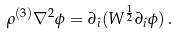<formula> <loc_0><loc_0><loc_500><loc_500>\rho ^ { ( 3 ) } \nabla ^ { 2 } \phi = \partial _ { \hat { \imath } } ( W ^ { \frac { 1 } { 2 } } \partial _ { \hat { \imath } } \phi ) \, .</formula> 